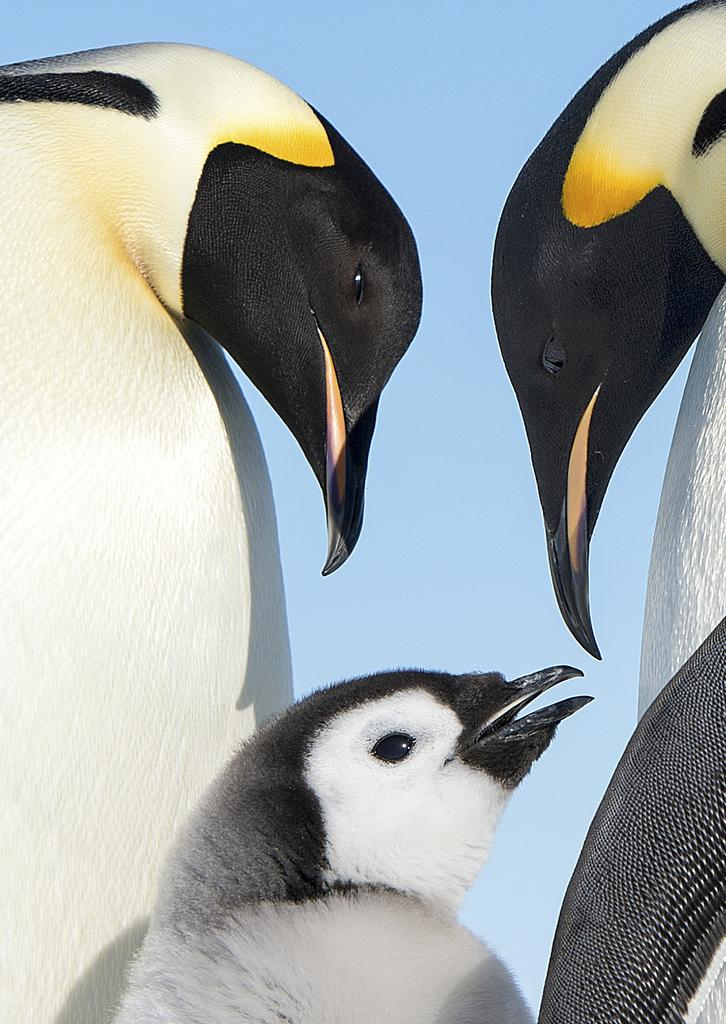How many penguins are in the image? There are three penguins in the image. What can be seen in the background of the image? There is a sky visible in the image. What type of ink is being used by the penguins in the image? There is no ink present in the image, as it features three penguins and a sky. 